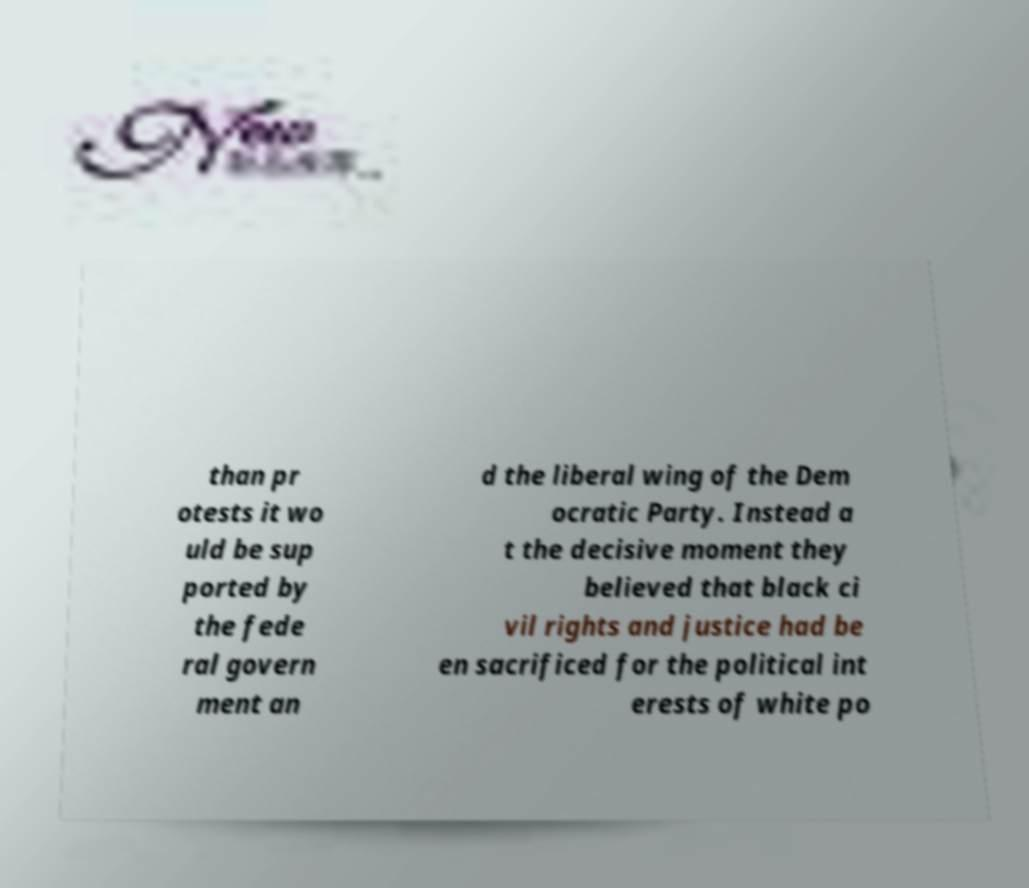Can you read and provide the text displayed in the image?This photo seems to have some interesting text. Can you extract and type it out for me? than pr otests it wo uld be sup ported by the fede ral govern ment an d the liberal wing of the Dem ocratic Party. Instead a t the decisive moment they believed that black ci vil rights and justice had be en sacrificed for the political int erests of white po 